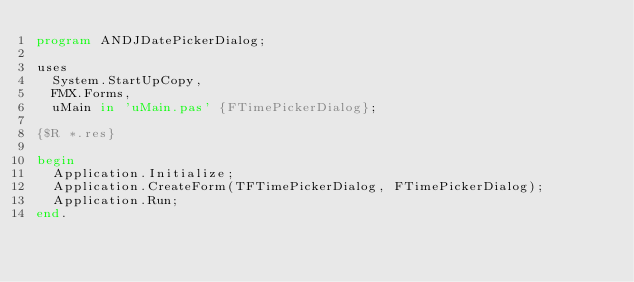<code> <loc_0><loc_0><loc_500><loc_500><_Pascal_>program ANDJDatePickerDialog;

uses
  System.StartUpCopy,
  FMX.Forms,
  uMain in 'uMain.pas' {FTimePickerDialog};

{$R *.res}

begin
  Application.Initialize;
  Application.CreateForm(TFTimePickerDialog, FTimePickerDialog);
  Application.Run;
end.
</code> 